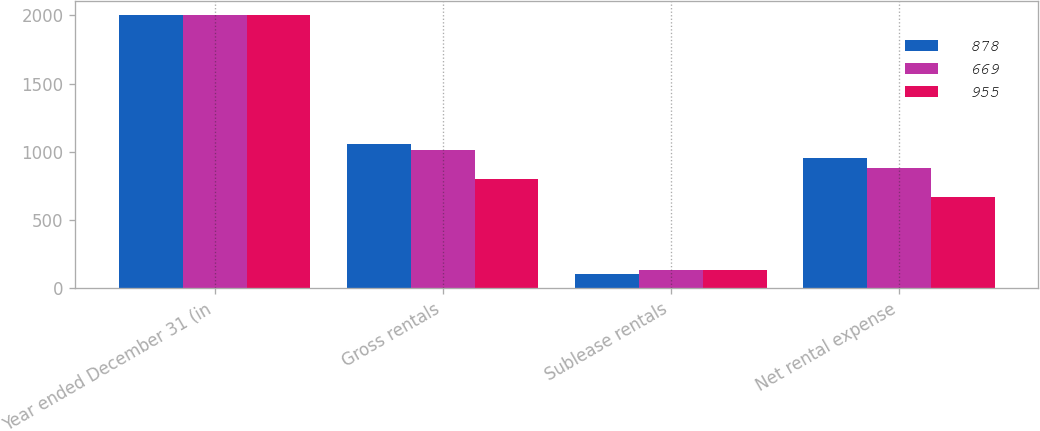<chart> <loc_0><loc_0><loc_500><loc_500><stacked_bar_chart><ecel><fcel>Year ended December 31 (in<fcel>Gross rentals<fcel>Sublease rentals<fcel>Net rental expense<nl><fcel>878<fcel>2003<fcel>1061<fcel>106<fcel>955<nl><fcel>669<fcel>2002<fcel>1012<fcel>134<fcel>878<nl><fcel>955<fcel>2001<fcel>804<fcel>135<fcel>669<nl></chart> 